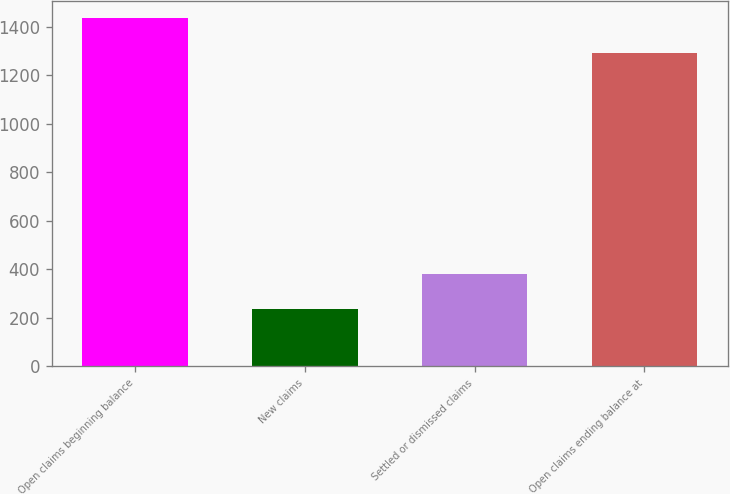<chart> <loc_0><loc_0><loc_500><loc_500><bar_chart><fcel>Open claims beginning balance<fcel>New claims<fcel>Settled or dismissed claims<fcel>Open claims ending balance at<nl><fcel>1437<fcel>235<fcel>381<fcel>1291<nl></chart> 